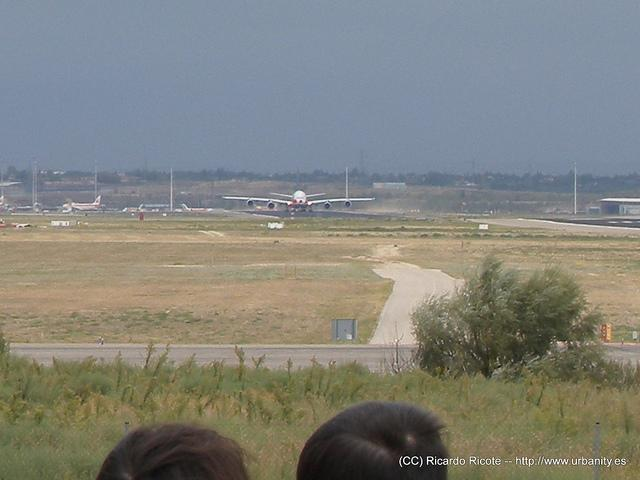Who gives the airplanes guidelines on where to take off and land?

Choices:
A) spies
B) wardens
C) air control
D) pilots wardens 